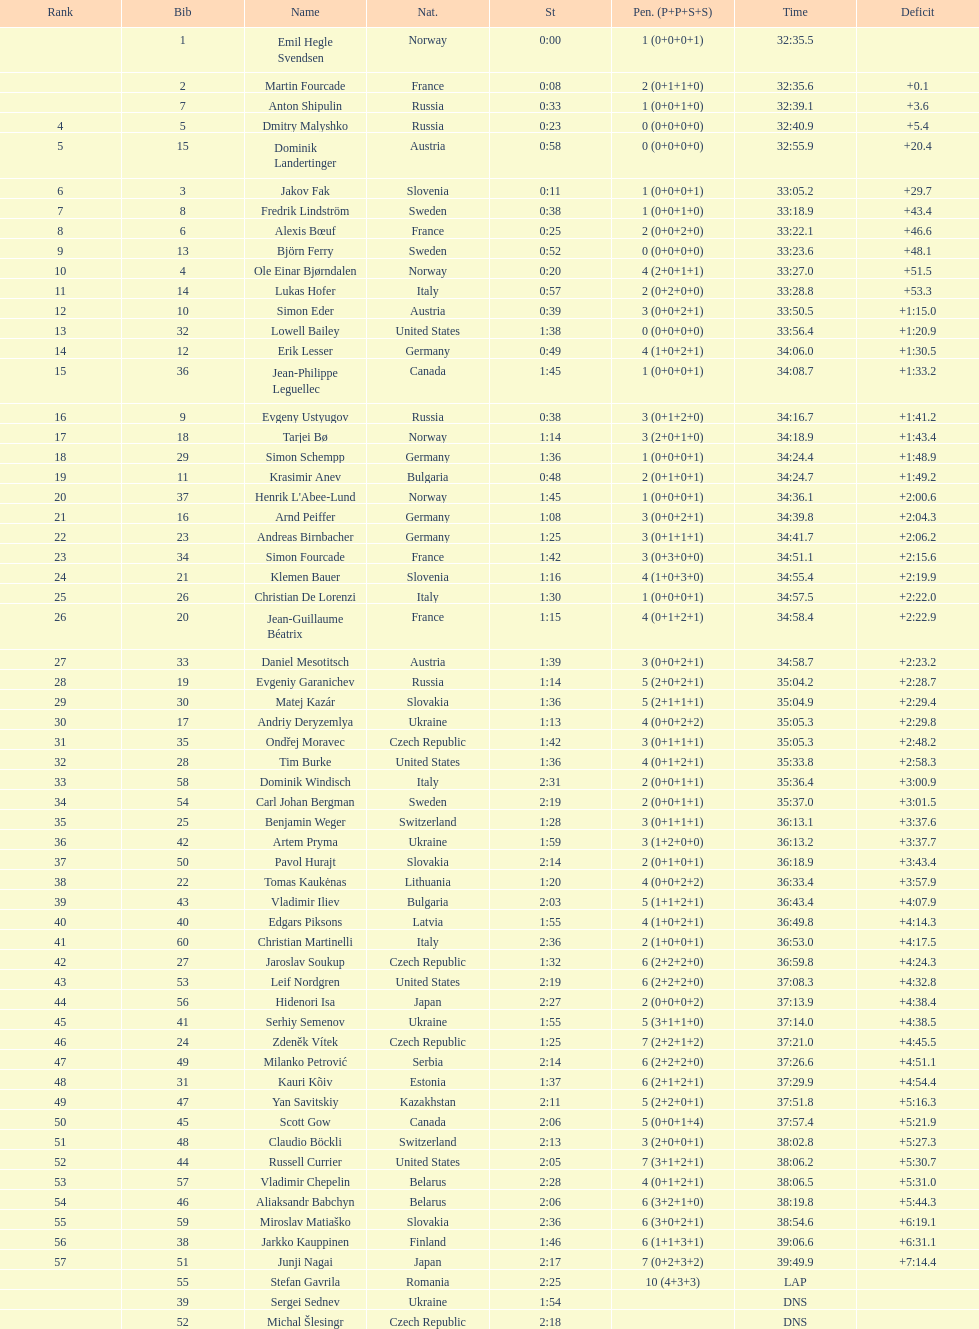Who is the top ranked runner of sweden? Fredrik Lindström. 